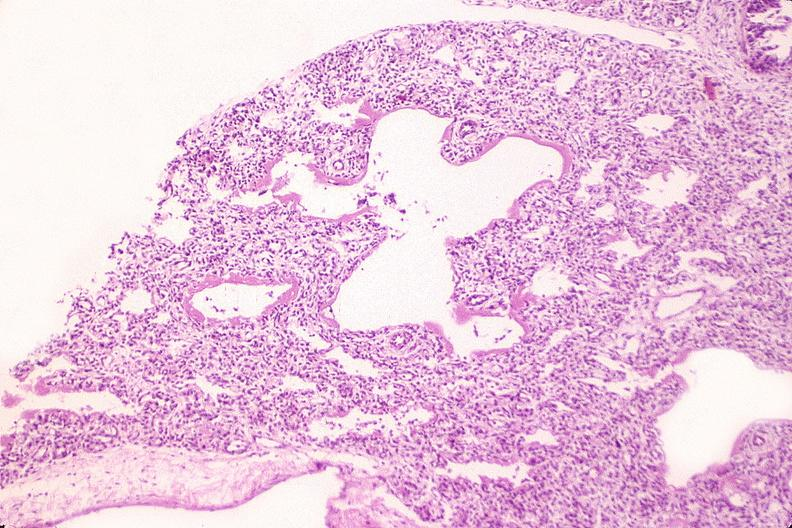s whipples disease present?
Answer the question using a single word or phrase. No 